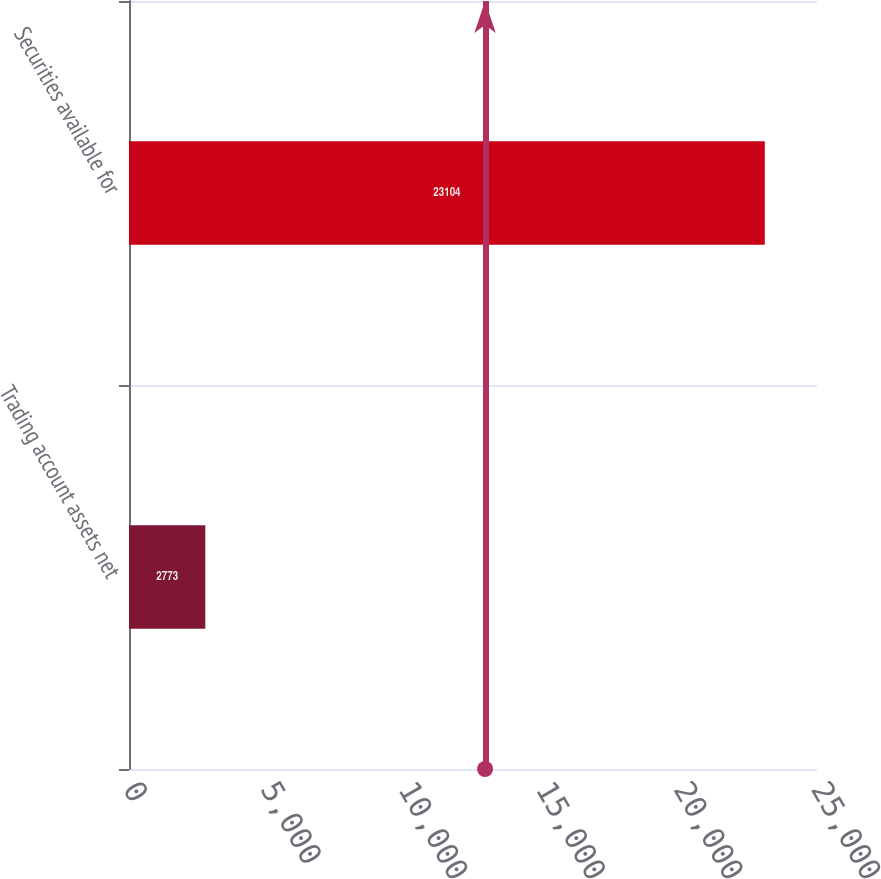Convert chart. <chart><loc_0><loc_0><loc_500><loc_500><bar_chart><fcel>Trading account assets net<fcel>Securities available for<nl><fcel>2773<fcel>23104<nl></chart> 